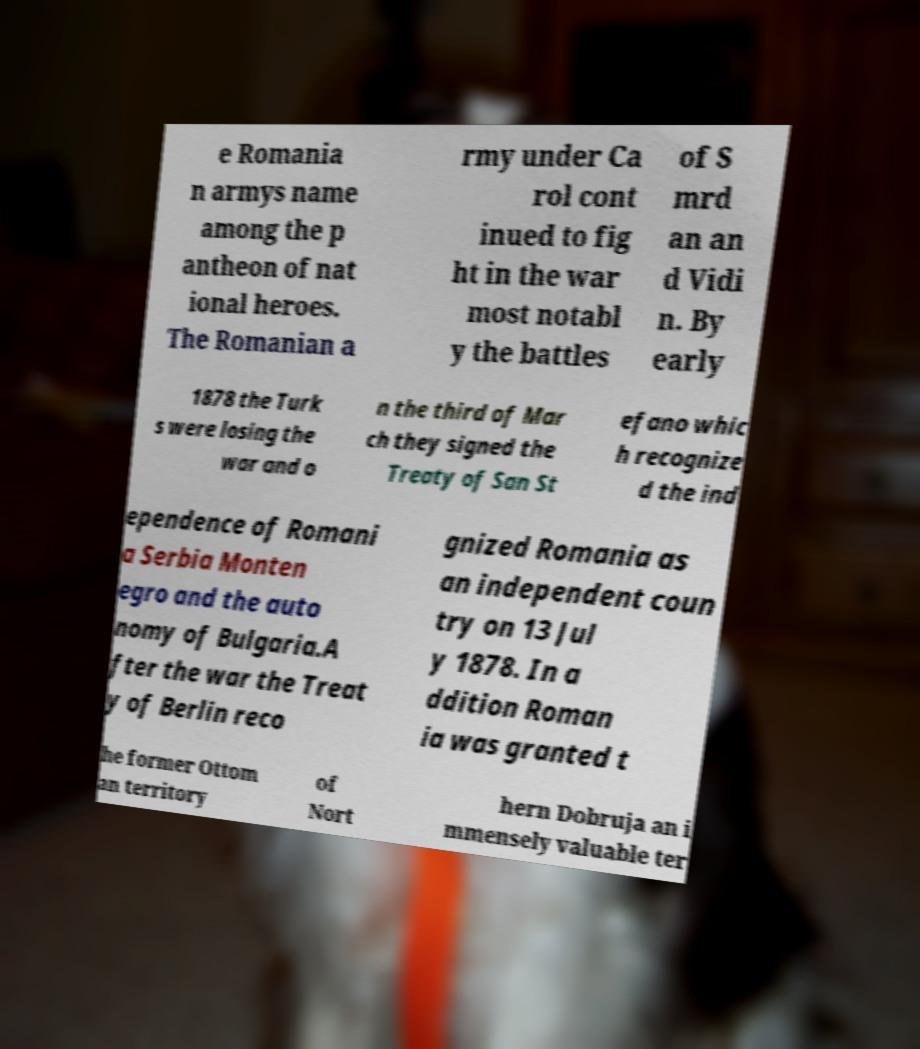Could you extract and type out the text from this image? e Romania n armys name among the p antheon of nat ional heroes. The Romanian a rmy under Ca rol cont inued to fig ht in the war most notabl y the battles of S mrd an an d Vidi n. By early 1878 the Turk s were losing the war and o n the third of Mar ch they signed the Treaty of San St efano whic h recognize d the ind ependence of Romani a Serbia Monten egro and the auto nomy of Bulgaria.A fter the war the Treat y of Berlin reco gnized Romania as an independent coun try on 13 Jul y 1878. In a ddition Roman ia was granted t he former Ottom an territory of Nort hern Dobruja an i mmensely valuable ter 